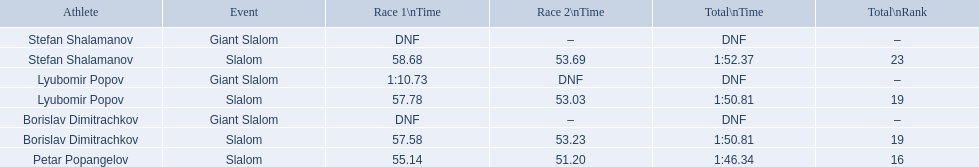Could you parse the entire table as a dict? {'header': ['Athlete', 'Event', 'Race 1\\nTime', 'Race 2\\nTime', 'Total\\nTime', 'Total\\nRank'], 'rows': [['Stefan Shalamanov', 'Giant Slalom', 'DNF', '–', 'DNF', '–'], ['Stefan Shalamanov', 'Slalom', '58.68', '53.69', '1:52.37', '23'], ['Lyubomir Popov', 'Giant Slalom', '1:10.73', 'DNF', 'DNF', '–'], ['Lyubomir Popov', 'Slalom', '57.78', '53.03', '1:50.81', '19'], ['Borislav Dimitrachkov', 'Giant Slalom', 'DNF', '–', 'DNF', '–'], ['Borislav Dimitrachkov', 'Slalom', '57.58', '53.23', '1:50.81', '19'], ['Petar Popangelov', 'Slalom', '55.14', '51.20', '1:46.34', '16']]} Which event is the giant slalom? Giant Slalom, Giant Slalom, Giant Slalom. Which one is lyubomir popov? Lyubomir Popov. What is race 1 tim? 1:10.73. 